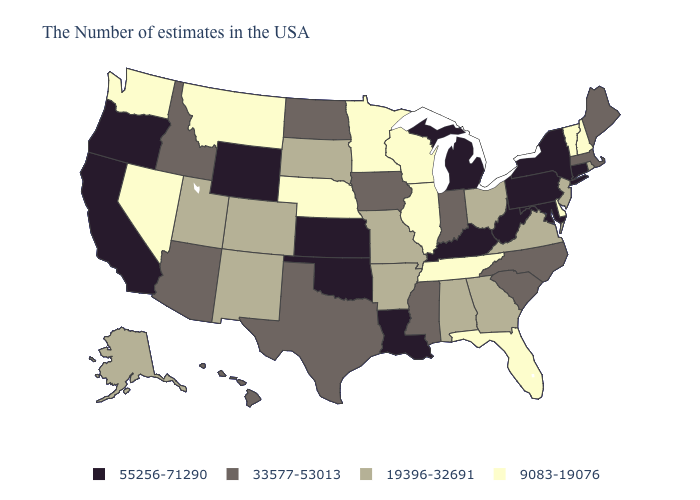Does Michigan have a higher value than Indiana?
Give a very brief answer. Yes. Among the states that border Florida , which have the lowest value?
Be succinct. Georgia, Alabama. Which states have the lowest value in the USA?
Quick response, please. New Hampshire, Vermont, Delaware, Florida, Tennessee, Wisconsin, Illinois, Minnesota, Nebraska, Montana, Nevada, Washington. Among the states that border South Carolina , does Georgia have the highest value?
Give a very brief answer. No. Does Nevada have the lowest value in the USA?
Answer briefly. Yes. What is the value of Pennsylvania?
Give a very brief answer. 55256-71290. Does Louisiana have the highest value in the USA?
Write a very short answer. Yes. Among the states that border Maryland , does Virginia have the highest value?
Answer briefly. No. What is the highest value in the South ?
Write a very short answer. 55256-71290. How many symbols are there in the legend?
Answer briefly. 4. Name the states that have a value in the range 33577-53013?
Write a very short answer. Maine, Massachusetts, North Carolina, South Carolina, Indiana, Mississippi, Iowa, Texas, North Dakota, Arizona, Idaho, Hawaii. Which states have the highest value in the USA?
Concise answer only. Connecticut, New York, Maryland, Pennsylvania, West Virginia, Michigan, Kentucky, Louisiana, Kansas, Oklahoma, Wyoming, California, Oregon. Which states hav the highest value in the South?
Give a very brief answer. Maryland, West Virginia, Kentucky, Louisiana, Oklahoma. How many symbols are there in the legend?
Quick response, please. 4. What is the value of Massachusetts?
Write a very short answer. 33577-53013. 